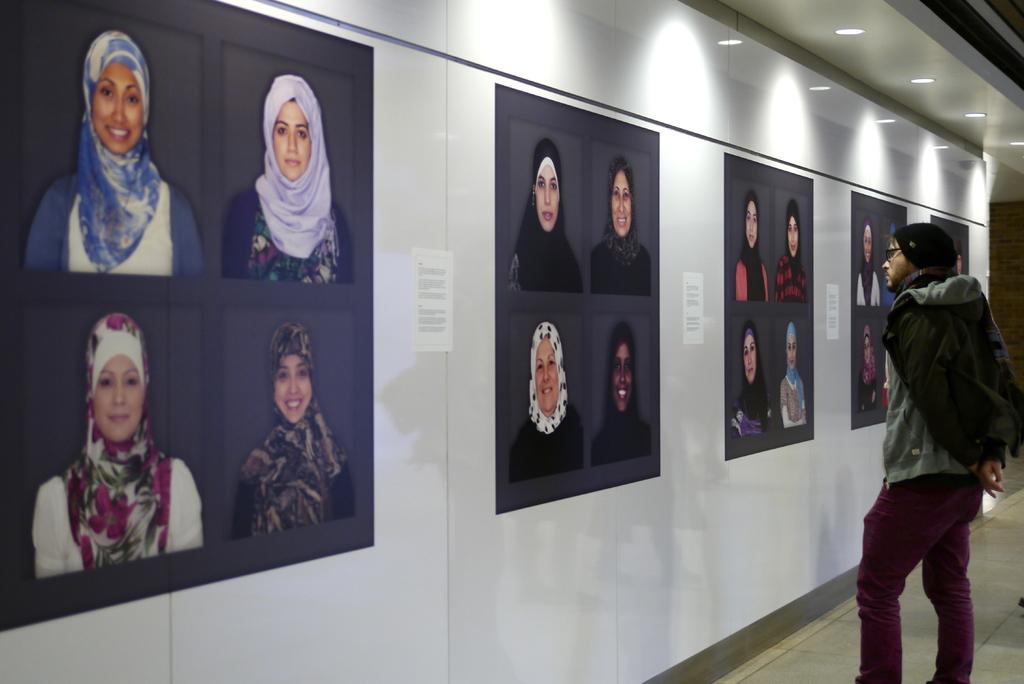What is the main subject in the foreground of the image? There is a man in the foreground of the image. Where is the man standing in relation to the wall? The man is standing near a wall. What can be seen attached to the wall? There are posts attached to the wall. What is visible at the top of the image? There are lights visible at the top of the image. What type of downtown area can be seen in the image? There is no downtown area present in the image; it features a man standing near a wall with posts and lights visible. 